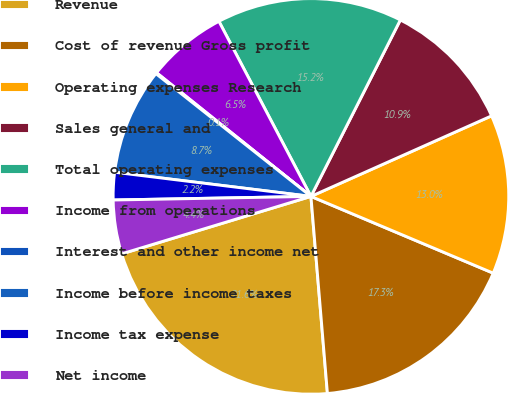Convert chart to OTSL. <chart><loc_0><loc_0><loc_500><loc_500><pie_chart><fcel>Revenue<fcel>Cost of revenue Gross profit<fcel>Operating expenses Research<fcel>Sales general and<fcel>Total operating expenses<fcel>Income from operations<fcel>Interest and other income net<fcel>Income before income taxes<fcel>Income tax expense<fcel>Net income<nl><fcel>21.64%<fcel>17.33%<fcel>13.02%<fcel>10.86%<fcel>15.17%<fcel>6.55%<fcel>0.09%<fcel>8.71%<fcel>2.24%<fcel>4.4%<nl></chart> 